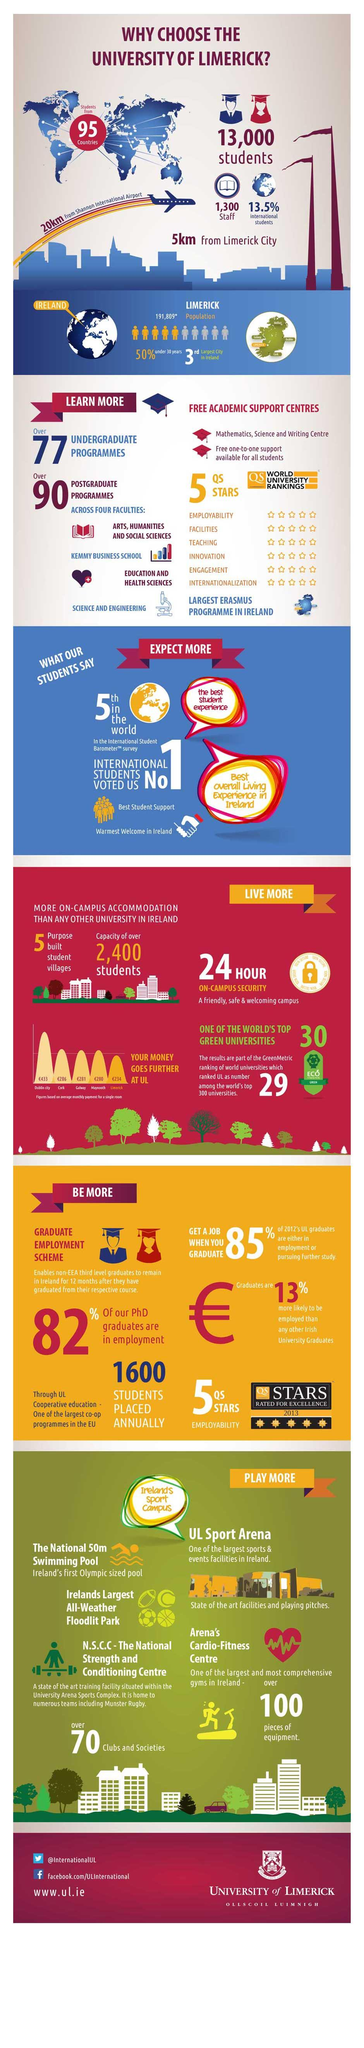Outline some significant characteristics in this image. The University of Limerick employs approximately 1,300 staff members in total. According to the data, 82% of PhD graduates from the University of Limerick are currently employed. The University of Limerick is ranked 5th in the world according to QS STARS. The distance from the University of Limerick to Limerick City is approximately 5 kilometers. According to statistics, 13.5% of the students enrolled at the University of Limerick are international students. 